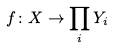<formula> <loc_0><loc_0><loc_500><loc_500>f \colon X \rightarrow \prod _ { i } Y _ { i }</formula> 